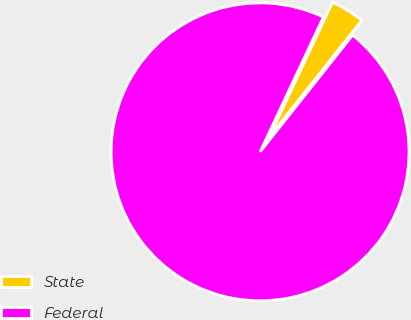<chart> <loc_0><loc_0><loc_500><loc_500><pie_chart><fcel>State<fcel>Federal<nl><fcel>3.68%<fcel>96.32%<nl></chart> 